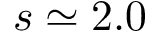<formula> <loc_0><loc_0><loc_500><loc_500>s \simeq 2 . 0</formula> 